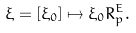<formula> <loc_0><loc_0><loc_500><loc_500>\xi = [ \xi _ { 0 } ] \mapsto \xi _ { 0 } R ^ { E } _ { p } .</formula> 